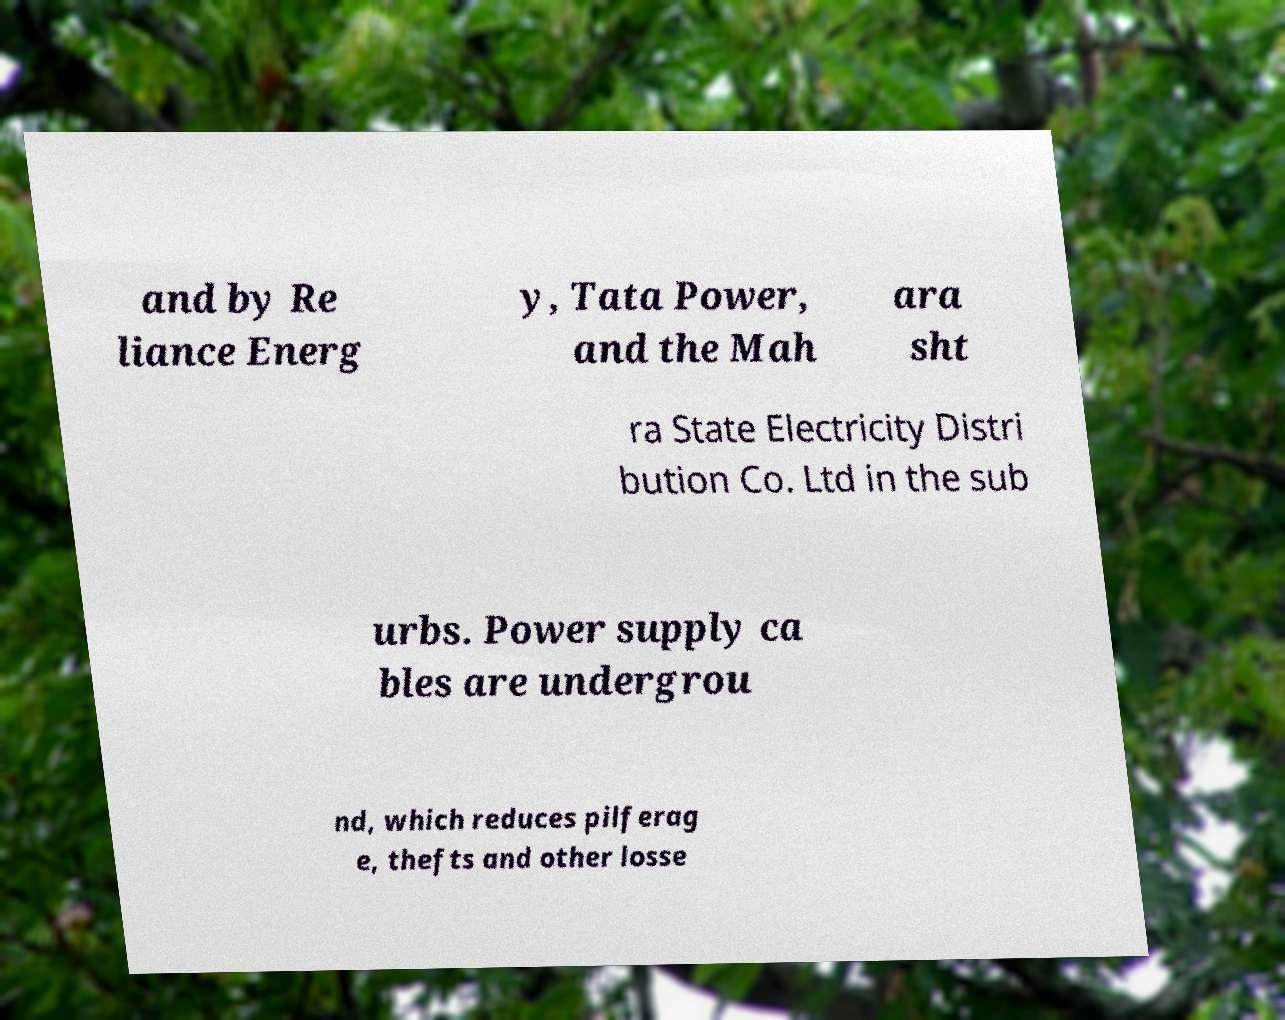Can you accurately transcribe the text from the provided image for me? and by Re liance Energ y, Tata Power, and the Mah ara sht ra State Electricity Distri bution Co. Ltd in the sub urbs. Power supply ca bles are undergrou nd, which reduces pilferag e, thefts and other losse 